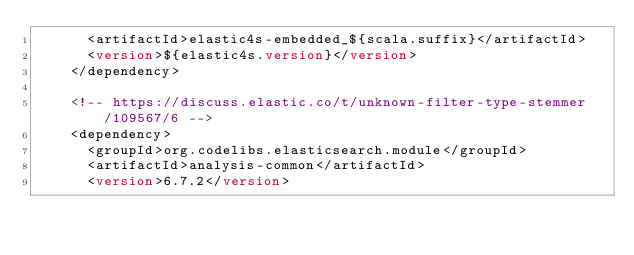<code> <loc_0><loc_0><loc_500><loc_500><_XML_>      <artifactId>elastic4s-embedded_${scala.suffix}</artifactId>
      <version>${elastic4s.version}</version>
    </dependency>

    <!-- https://discuss.elastic.co/t/unknown-filter-type-stemmer/109567/6 -->
    <dependency>
      <groupId>org.codelibs.elasticsearch.module</groupId>
      <artifactId>analysis-common</artifactId>
      <version>6.7.2</version></code> 